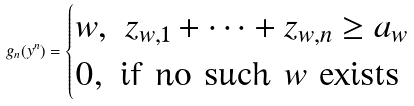Convert formula to latex. <formula><loc_0><loc_0><loc_500><loc_500>g _ { n } ( y ^ { n } ) = \begin{cases} w , \ z _ { w , 1 } + \dots + z _ { w , n } \geq a _ { w } \\ 0 , \ \text {if no such $w$ exists} \end{cases}</formula> 